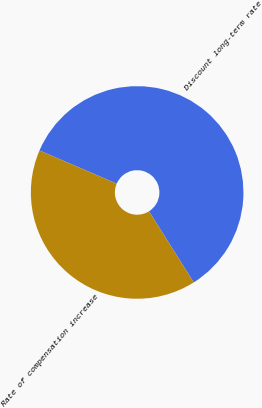Convert chart. <chart><loc_0><loc_0><loc_500><loc_500><pie_chart><fcel>Discount long-term rate<fcel>Rate of compensation increase<nl><fcel>59.6%<fcel>40.4%<nl></chart> 